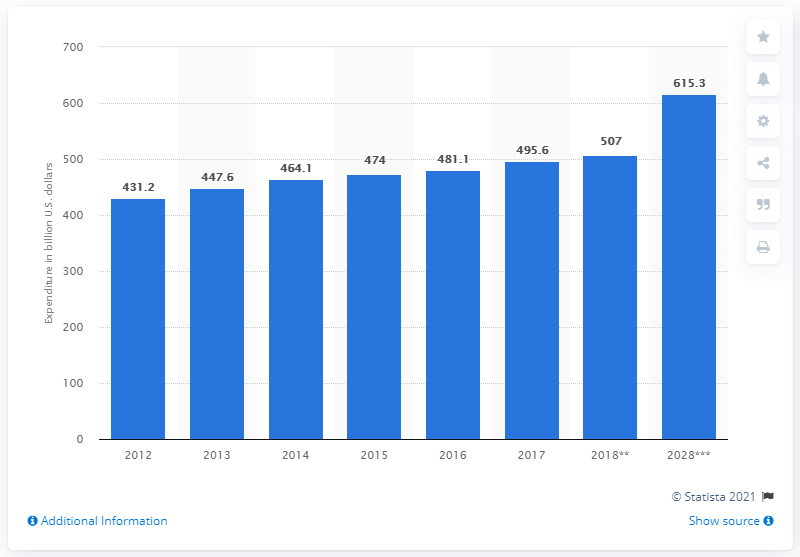Point out several critical features in this image. The estimated value of outbound travel spending in the United States in 2018 was approximately $507 billion. It is expected that in 2028, a significant amount of money will be spent on outbound travel in the United States. 